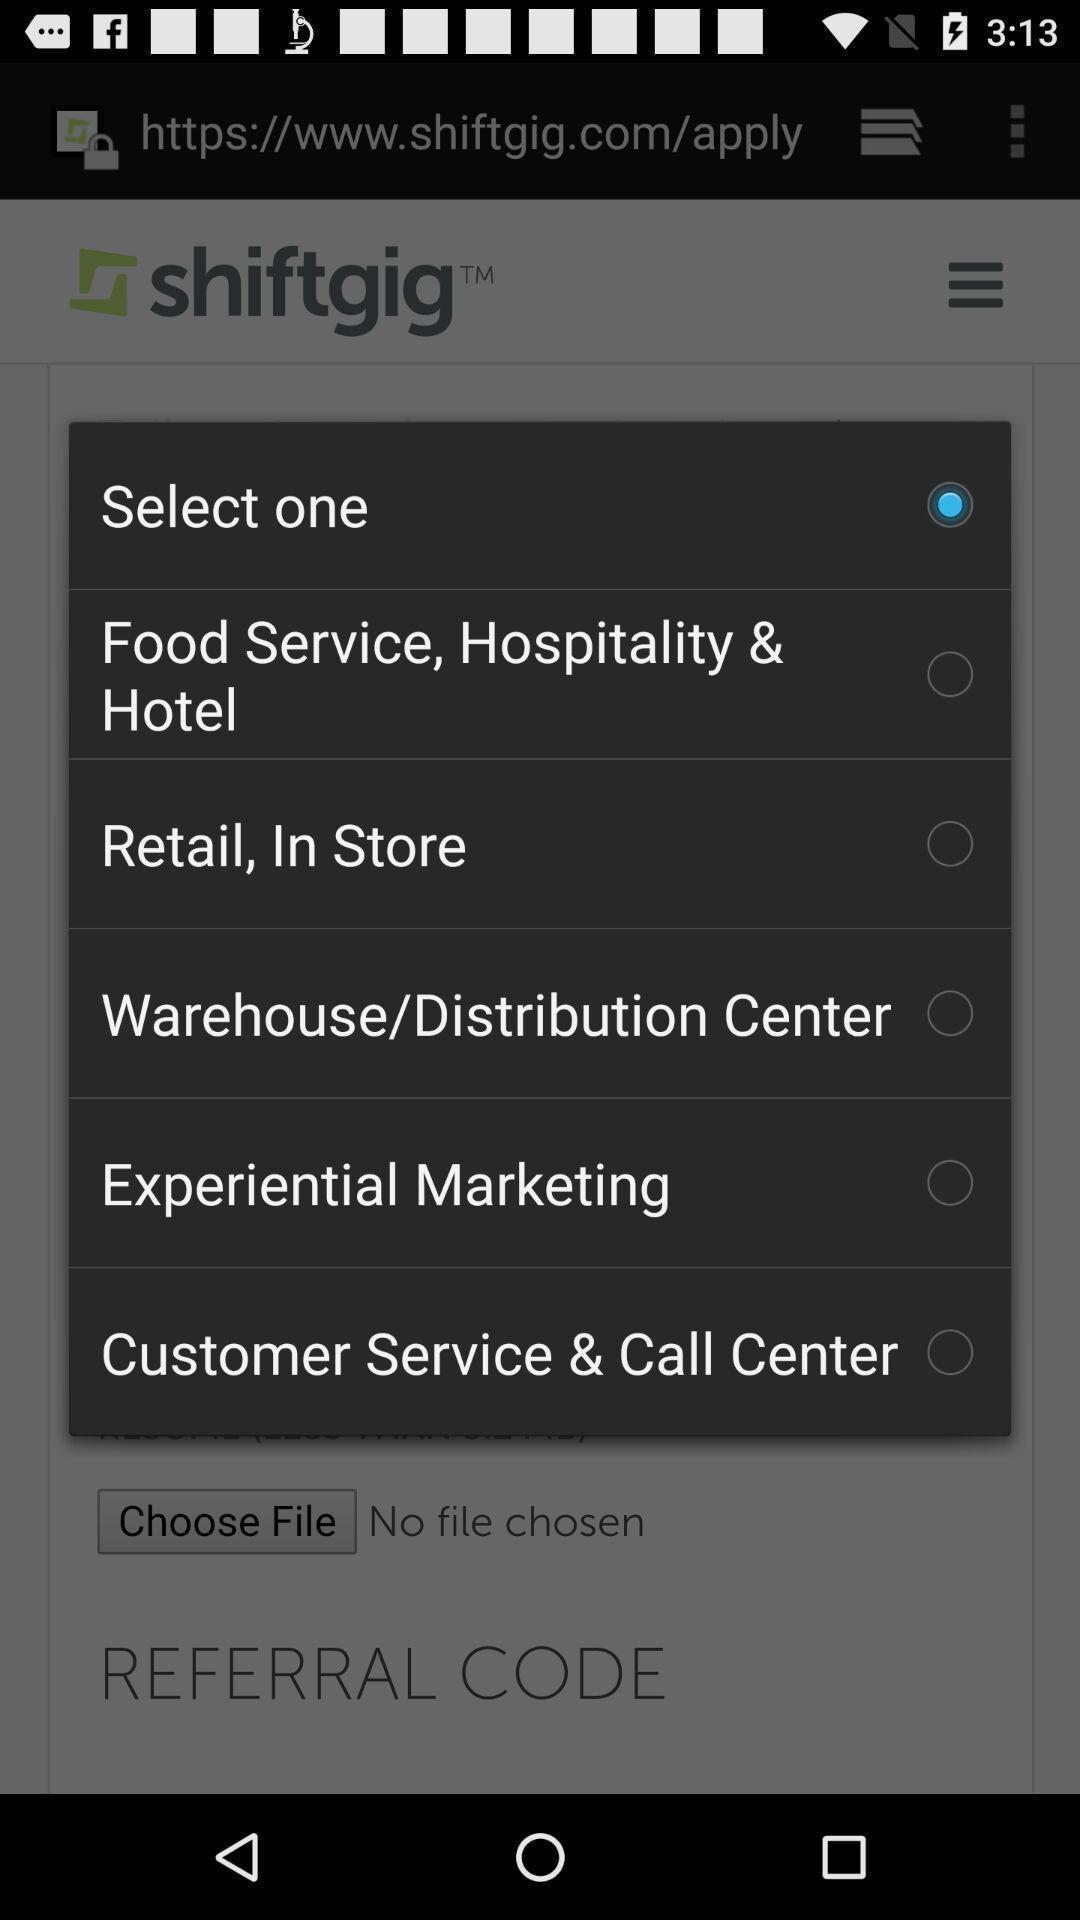Tell me about the visual elements in this screen capture. Pop-up for selection of various service categories. 